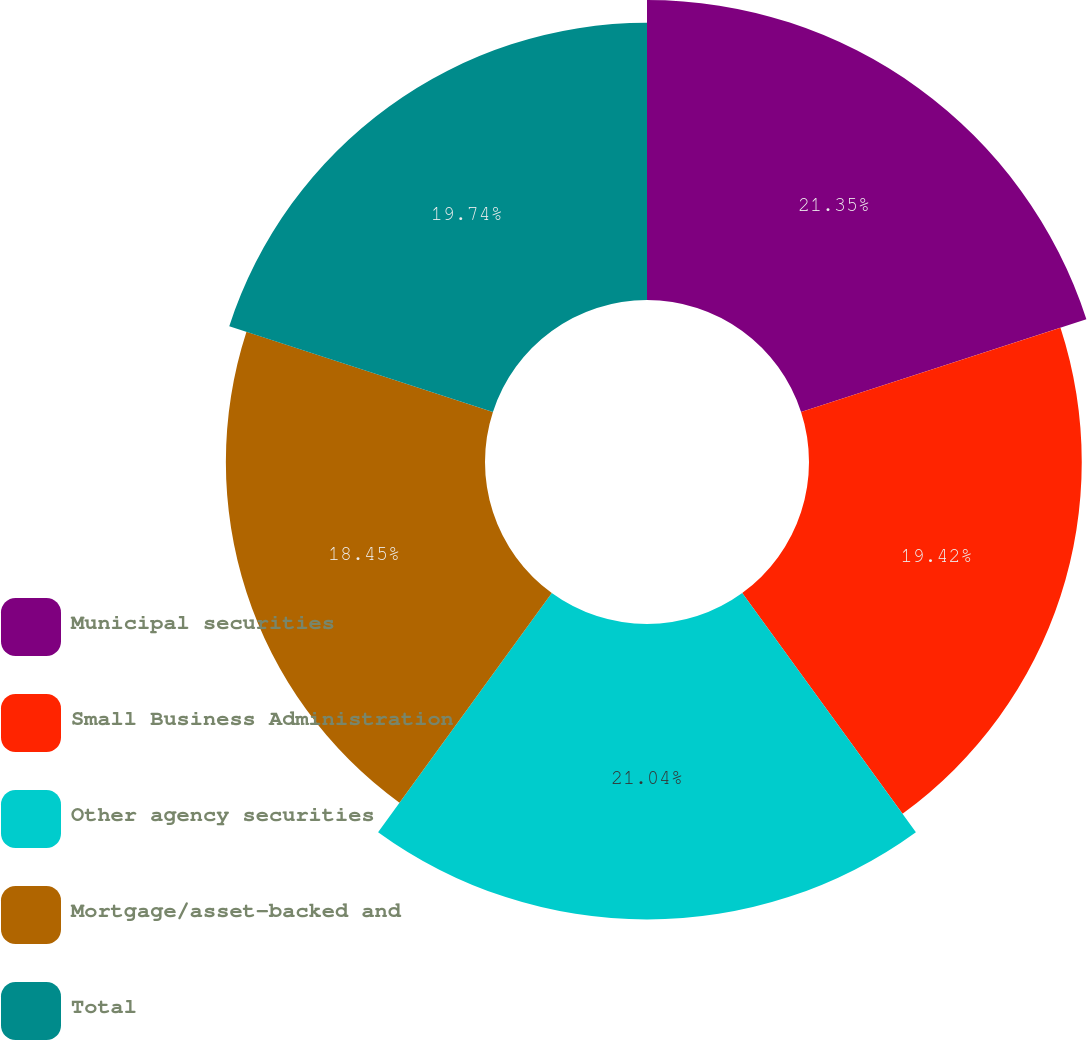Convert chart to OTSL. <chart><loc_0><loc_0><loc_500><loc_500><pie_chart><fcel>Municipal securities<fcel>Small Business Administration<fcel>Other agency securities<fcel>Mortgage/asset-backed and<fcel>Total<nl><fcel>21.36%<fcel>19.42%<fcel>21.04%<fcel>18.45%<fcel>19.74%<nl></chart> 